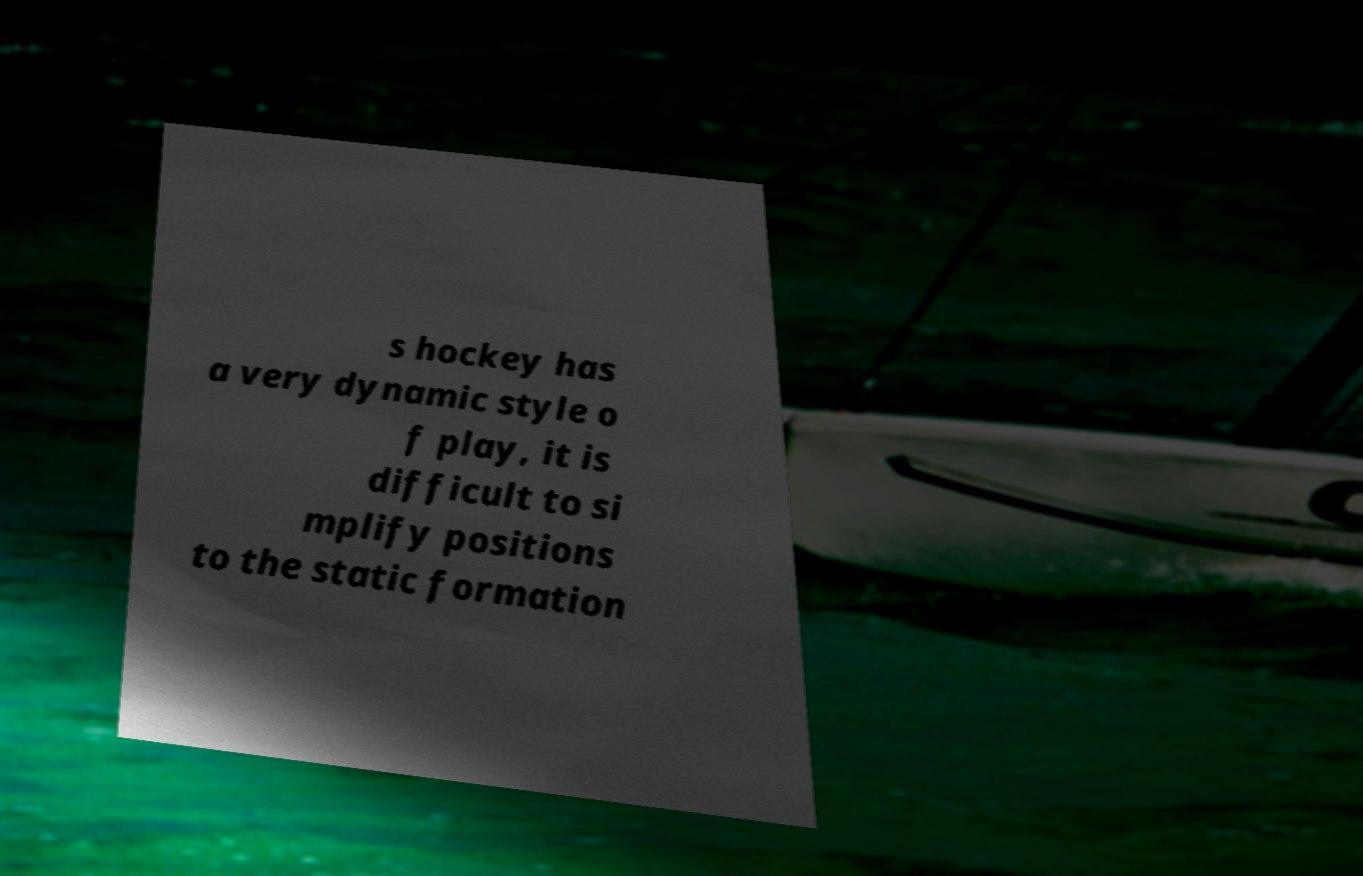Please identify and transcribe the text found in this image. s hockey has a very dynamic style o f play, it is difficult to si mplify positions to the static formation 